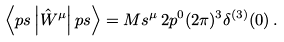<formula> <loc_0><loc_0><loc_500><loc_500>\left \langle p s \left | { \hat { W } } ^ { \mu } \right | p s \right \rangle = M s ^ { \mu } \, 2 p ^ { 0 } ( 2 \pi ) ^ { 3 } \delta ^ { ( 3 ) } ( 0 ) \, .</formula> 